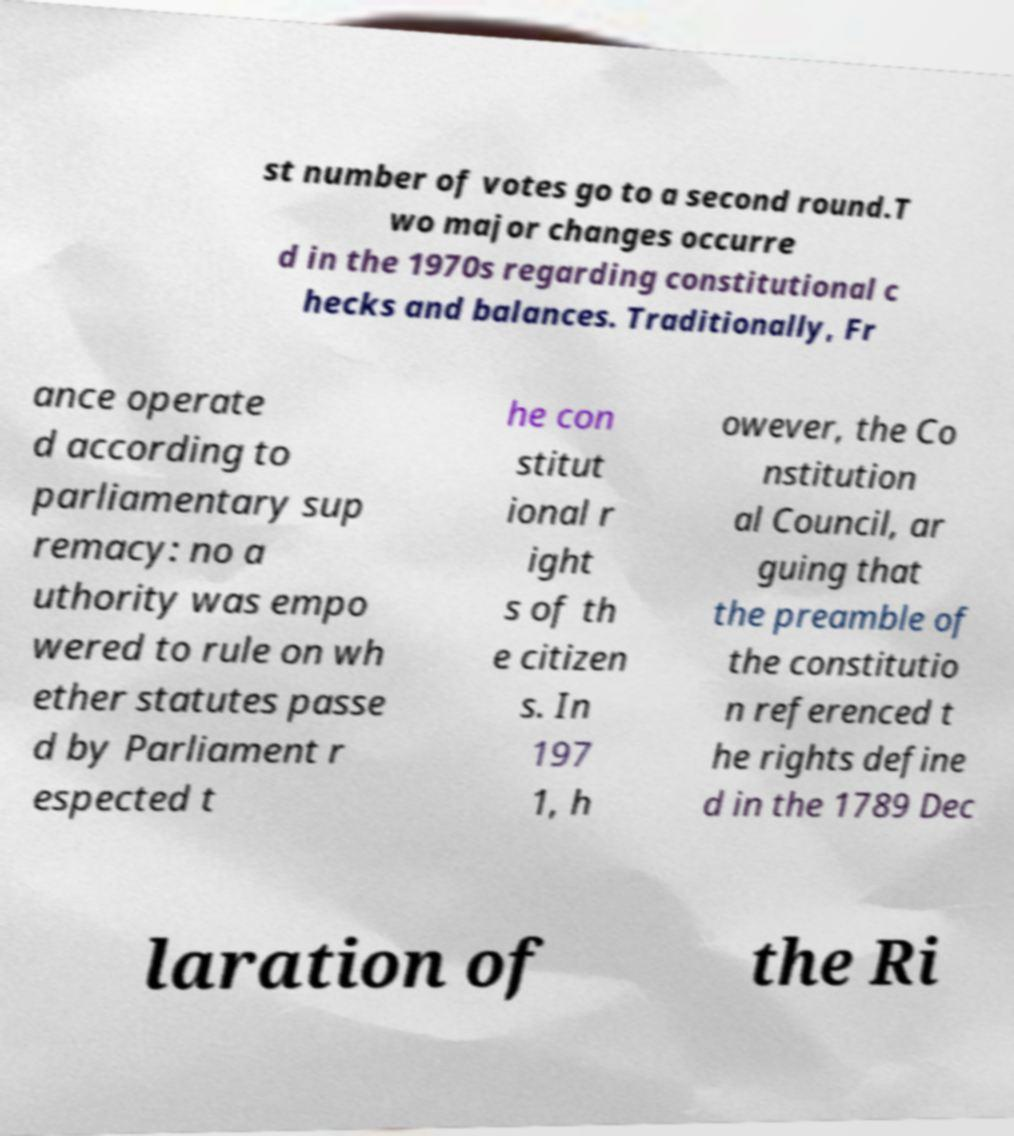I need the written content from this picture converted into text. Can you do that? st number of votes go to a second round.T wo major changes occurre d in the 1970s regarding constitutional c hecks and balances. Traditionally, Fr ance operate d according to parliamentary sup remacy: no a uthority was empo wered to rule on wh ether statutes passe d by Parliament r espected t he con stitut ional r ight s of th e citizen s. In 197 1, h owever, the Co nstitution al Council, ar guing that the preamble of the constitutio n referenced t he rights define d in the 1789 Dec laration of the Ri 